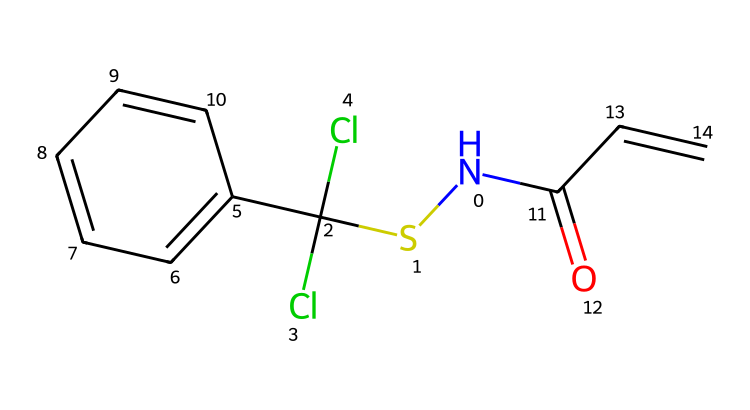What is the molecular formula of captan? To find the molecular formula, we need to count the number of each type of atom represented in the SMILES: 1 nitrogen (N), 2 chlorines (Cl), 9 carbons (C), 7 hydrogens (H), and 1 oxygen (O). Therefore, the molecular formula is C9H9Cl2N1O1.
Answer: C9H9Cl2NO How many rings are present in the structure? Analyzing the SMILES representation reveals there is one benzene ring (C1=CC=CC=C1), which consists of six carbon atoms connected in a cyclic manner.
Answer: 1 What type of functional groups are present in captan? The structure contains a thioamide group (N(SC(Cl)(Cl)...)), a ketone group (C(=O)), and an alkene (C=C) that contribute to its classification as a fungicide.
Answer: thioamide, ketone, alkene What is the primary use of captan in gardening? Captan is a broad-spectrum fungicide, primarily used to control fungal diseases in various plants. Its structure allows it to interfere with the growth of fungi, making it effective in preventing and treating these diseases.
Answer: fungicide What does the presence of chlorine atoms indicate about captan's properties? Chlorine atoms (Cl) are often associated with increased antimicrobial activity and stability in chemical compounds. In captan, they enhance its effectiveness as a fungicide while also impacting its environmental persistence.
Answer: increased antimicrobial activity and stability 